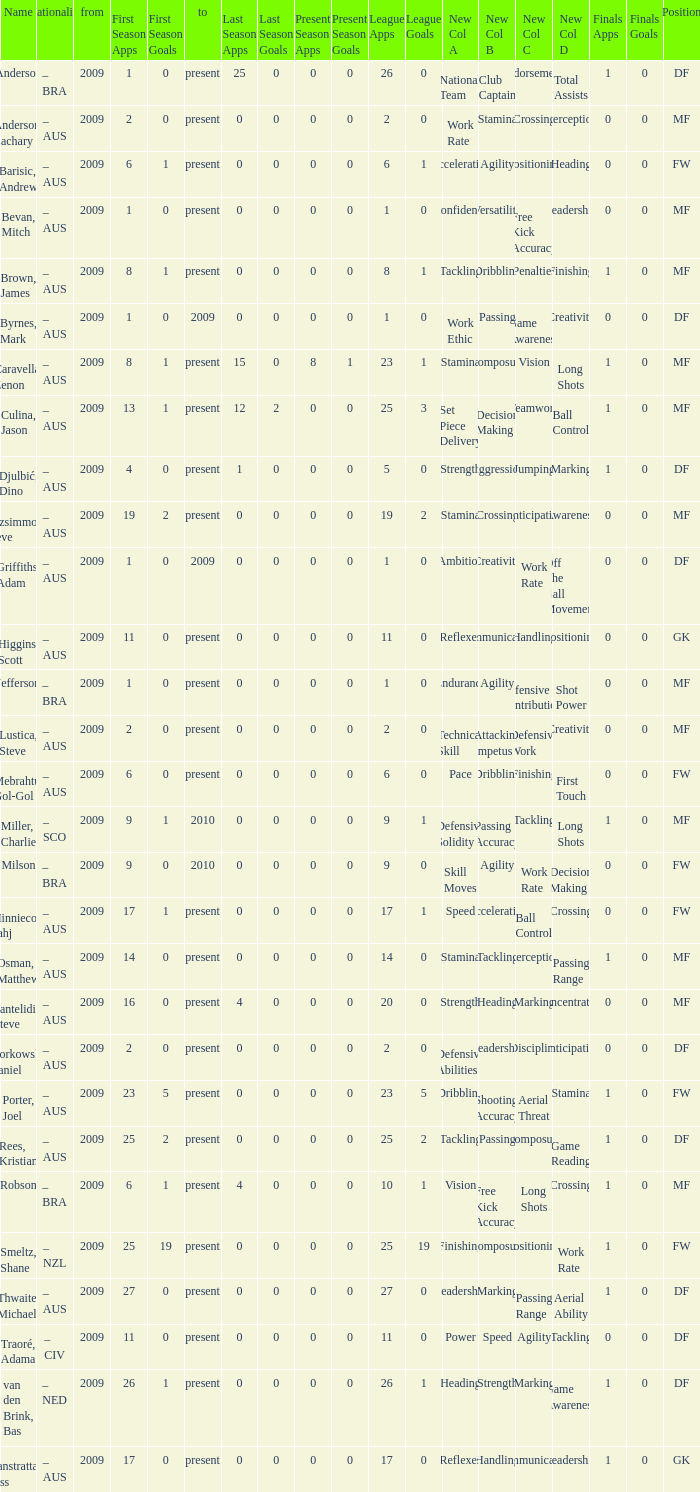Name the position for van den brink, bas DF. 